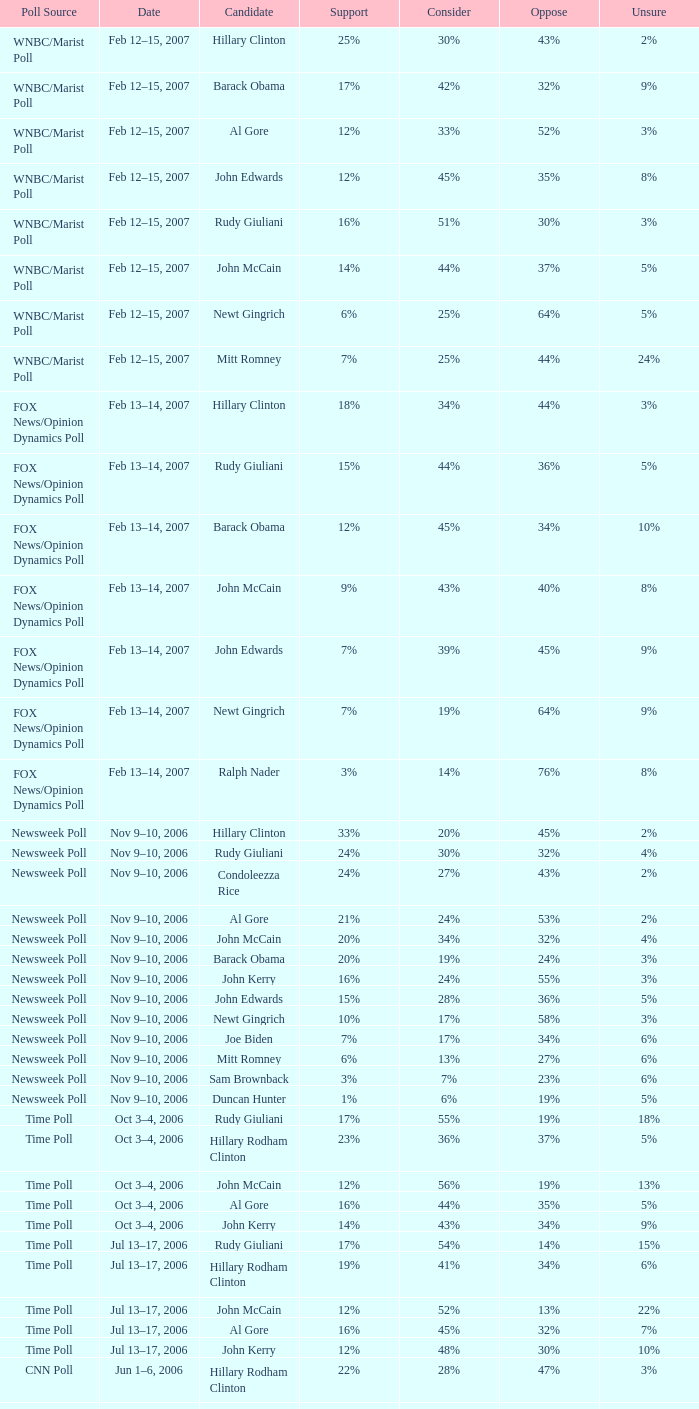Based on the wnbc/marist poll indicating 8% of people were uncertain, what proportion of individuals were against the candidate? 35%. 